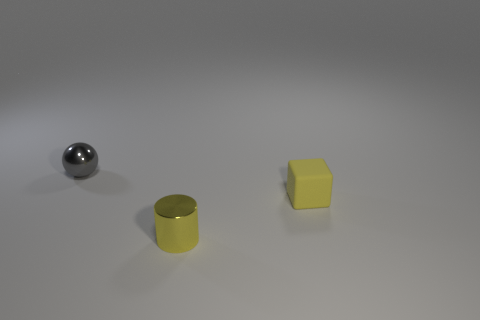What could be the possible sizes of these objects in real-life terms? While there's no reference for scale, these objects could realistically vary in size. The cube and cylinder might be similar in size to everyday objects like dice or a can, while the sphere could range from something small like a marble to something larger, like a bowling ball, depending on their actual dimensions. 